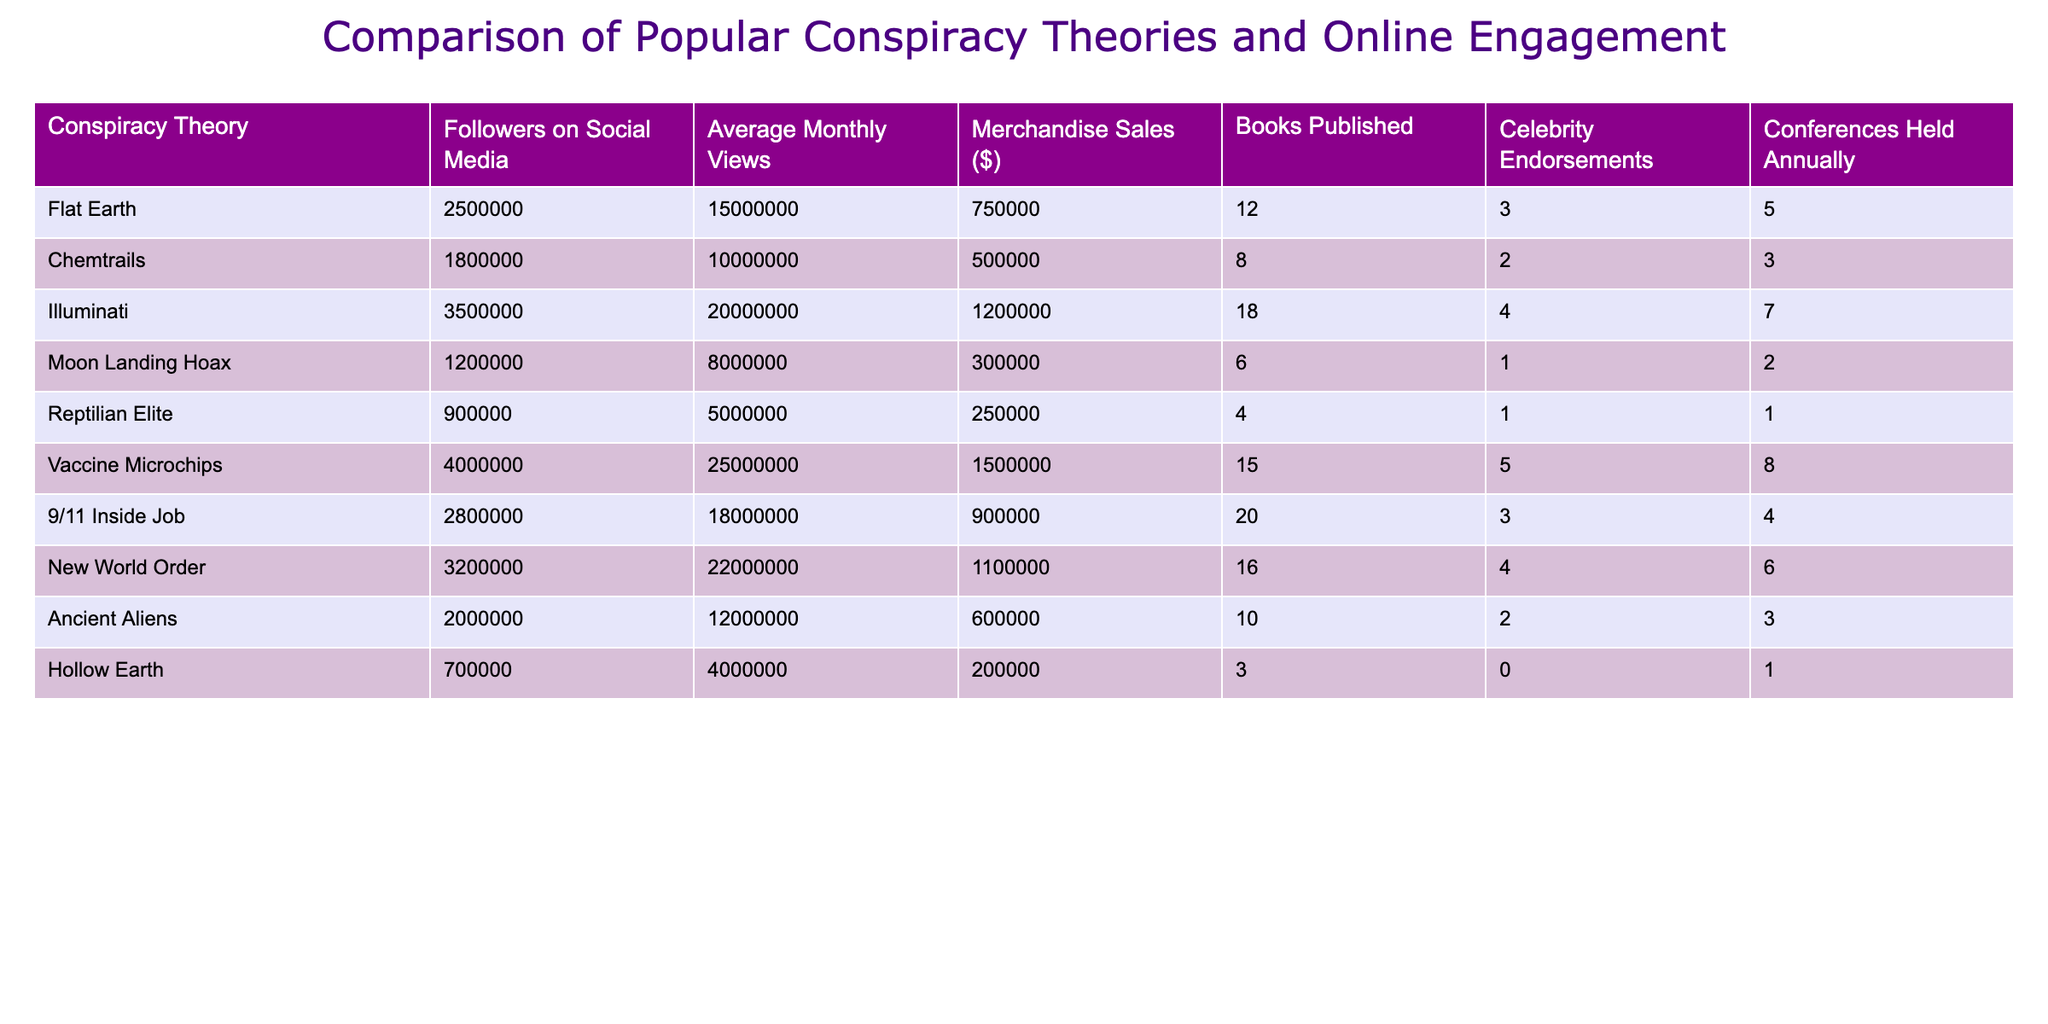What is the merchandise sales for the Illuminati conspiracy theory? The merchandise sales for the Illuminati can be directly found in the table under the "Merchandise Sales ($)" column. For the Illuminati, it shows 1200000.
Answer: 1200000 Which conspiracy theory has the highest number of followers on social media? Looking at the "Followers on Social Media" column, the highest number is 4000000, which corresponds to the "Vaccine Microchips" conspiracy theory.
Answer: Vaccine Microchips What is the total number of books published across all conspiracy theories listed? I sum the books published for all conspiracy theories: 12 (Flat Earth) + 8 (Chemtrails) + 18 (Illuminati) + 6 (Moon Landing Hoax) + 4 (Reptilian Elite) + 15 (Vaccine Microchips) + 20 (9/11 Inside Job) + 16 (New World Order) + 10 (Ancient Aliens) + 3 (Hollow Earth) =  12 + 8 + 18 + 6 + 4 + 15 + 20 + 16 + 10 + 3 =  112 books published in total.
Answer: 112 Is it true that the Hollow Earth theory has more annual conferences held than the Reptilian Elite theory? By comparing the "Conferences Held Annually" column, Hollow Earth has 1 conference while Reptilian Elite has 1 as well. Thus, they are equal and the statement is false.
Answer: No What is the average number of average monthly views for all conspiracy theories? To calculate the average, add the monthly views: 15000000 + 10000000 + 20000000 + 8000000 + 5000000 + 25000000 + 18000000 + 22000000 + 12000000 + 4000000 = 120000000. Then, divide by the number of theories, which is 10. So, 120000000 / 10 = 12000000 average monthly views.
Answer: 12000000 Which conspiracy theory received the least celebrity endorsements? The "Celebrity Endorsements" column shows the least value is 0 for Hollow Earth. Thus, Hollow Earth received the least celebrity endorsements.
Answer: Hollow Earth How many more merchandise sales does the Vaccine Microchips have compared to the Reptilian Elite? For Vaccine Microchips, the sales are 1500000 and for Reptilian Elite, they are 250000. The difference is 1500000 - 250000 = 1250000.
Answer: 1250000 Which conspiracy theory has more total annual conferences than the average across all theories? The average in the "Conferences Held Annually" column is calculated as (5 + 3 + 7 + 2 + 1 + 8 + 4 + 6 + 3 + 1) / 10 = 4. The theories with more than this figure are Illuminati (7), Vaccine Microchips (8), and New World Order (6).
Answer: Illuminati, Vaccine Microchips, New World Order 